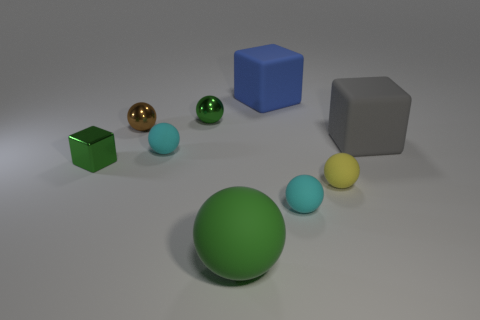Subtract all cyan balls. How many balls are left? 4 Subtract all small metallic spheres. How many spheres are left? 4 Subtract all red spheres. Subtract all gray cubes. How many spheres are left? 6 Add 1 tiny green objects. How many objects exist? 10 Subtract all blocks. How many objects are left? 6 Subtract all purple matte cylinders. Subtract all brown metal things. How many objects are left? 8 Add 6 large matte blocks. How many large matte blocks are left? 8 Add 2 gray matte blocks. How many gray matte blocks exist? 3 Subtract 0 purple cylinders. How many objects are left? 9 